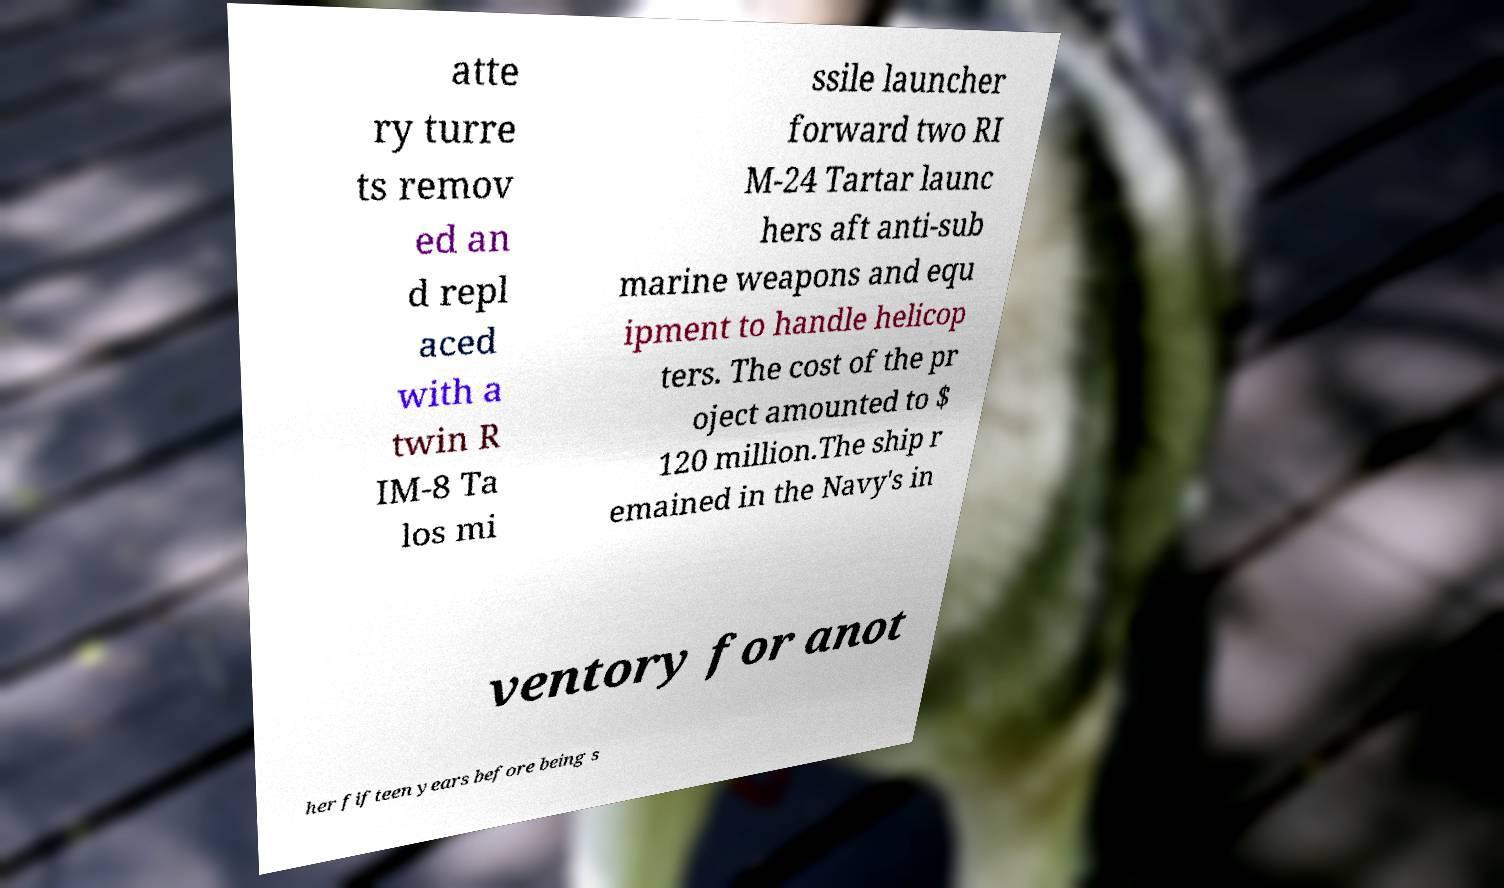Please read and relay the text visible in this image. What does it say? atte ry turre ts remov ed an d repl aced with a twin R IM-8 Ta los mi ssile launcher forward two RI M-24 Tartar launc hers aft anti-sub marine weapons and equ ipment to handle helicop ters. The cost of the pr oject amounted to $ 120 million.The ship r emained in the Navy's in ventory for anot her fifteen years before being s 